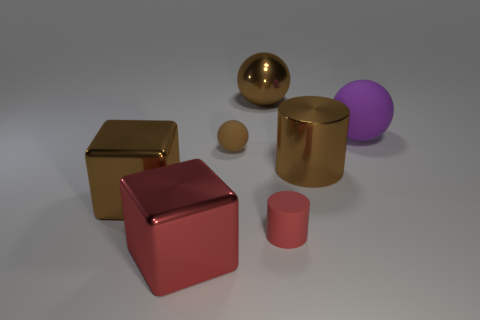Does the big purple object have the same shape as the brown rubber object? Indeed, the large purple object, which appears to be a sphere, shares the same geometric form as the small brown object. Both objects are three-dimensional shapes with every point on their surfaces equidistant from their centers, which is the defining characteristic of spheres. 